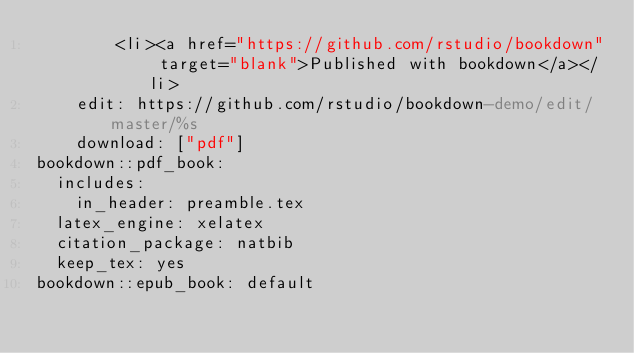Convert code to text. <code><loc_0><loc_0><loc_500><loc_500><_YAML_>        <li><a href="https://github.com/rstudio/bookdown" target="blank">Published with bookdown</a></li>
    edit: https://github.com/rstudio/bookdown-demo/edit/master/%s
    download: ["pdf"]
bookdown::pdf_book:
  includes:
    in_header: preamble.tex
  latex_engine: xelatex
  citation_package: natbib
  keep_tex: yes
bookdown::epub_book: default
</code> 